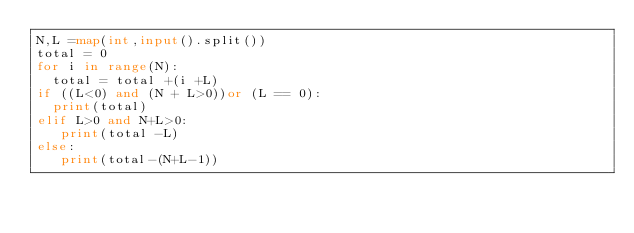<code> <loc_0><loc_0><loc_500><loc_500><_Python_>N,L =map(int,input().split())
total = 0
for i in range(N):
  total = total +(i +L)
if ((L<0) and (N + L>0))or (L == 0):
  print(total)
elif L>0 and N+L>0:
   print(total -L)
else:
   print(total-(N+L-1))

</code> 